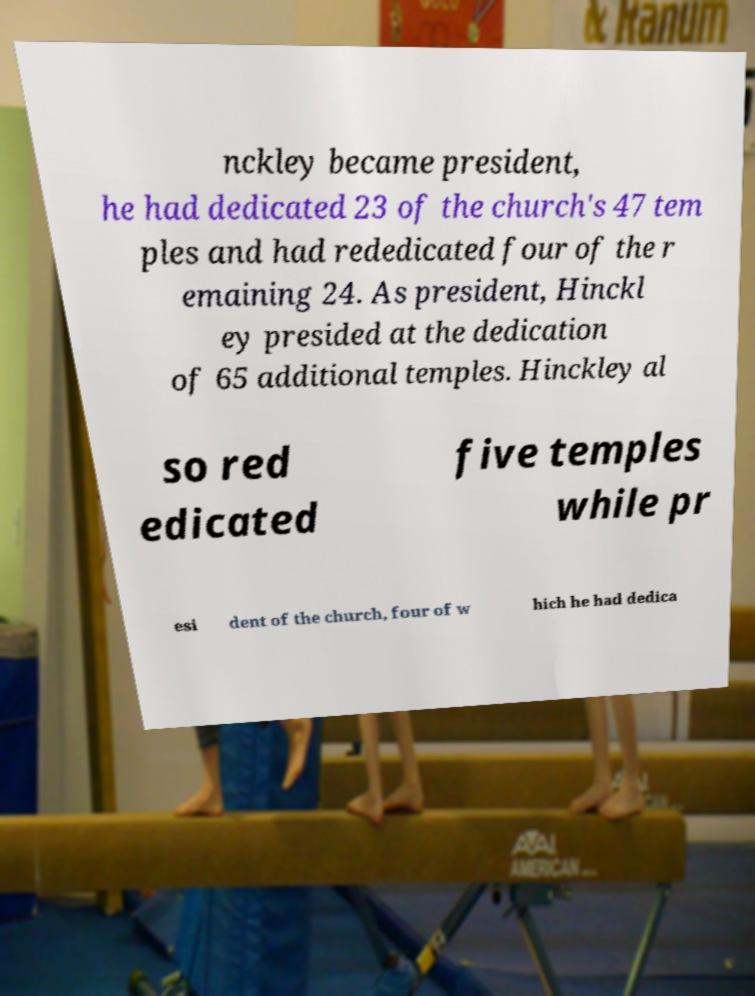Can you accurately transcribe the text from the provided image for me? nckley became president, he had dedicated 23 of the church's 47 tem ples and had rededicated four of the r emaining 24. As president, Hinckl ey presided at the dedication of 65 additional temples. Hinckley al so red edicated five temples while pr esi dent of the church, four of w hich he had dedica 